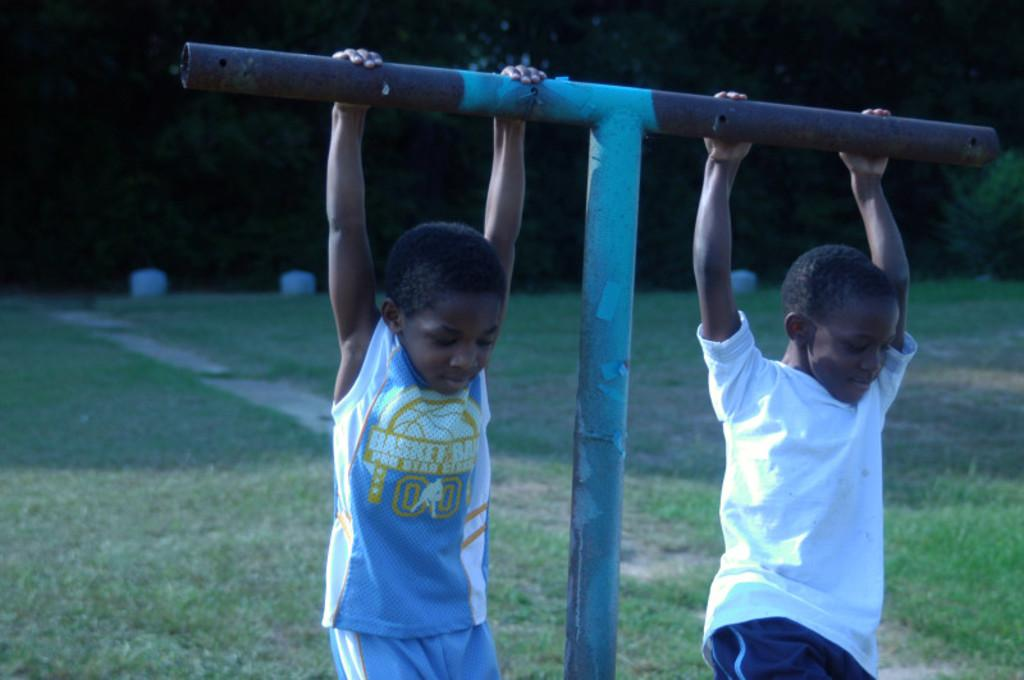How many boys are in the image? There are two boys in the image. What are the boys wearing? The boys are wearing t-shirts and shorts. What are the boys doing in the image? The boys are hanging onto a metal rod. What is the ground made of in the image? There is grass on the ground in the image. What can be seen in the background of the image? There are many trees in the background of the image. What type of berry can be seen growing on the metal rod in the image? There are no berries present in the image, and the metal rod is not a plant that can grow berries. 